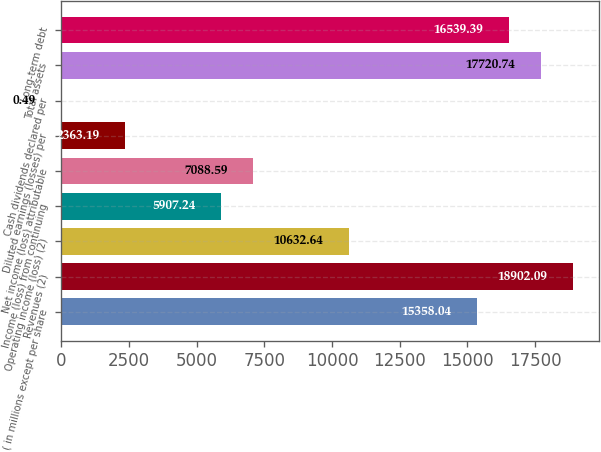Convert chart to OTSL. <chart><loc_0><loc_0><loc_500><loc_500><bar_chart><fcel>( in millions except per share<fcel>Revenues (2)<fcel>Operating income (loss) (2)<fcel>Income (loss) from continuing<fcel>Net income (loss) attributable<fcel>Diluted earnings (losses) per<fcel>Cash dividends declared per<fcel>Total assets<fcel>Long-term debt<nl><fcel>15358<fcel>18902.1<fcel>10632.6<fcel>5907.24<fcel>7088.59<fcel>2363.19<fcel>0.49<fcel>17720.7<fcel>16539.4<nl></chart> 